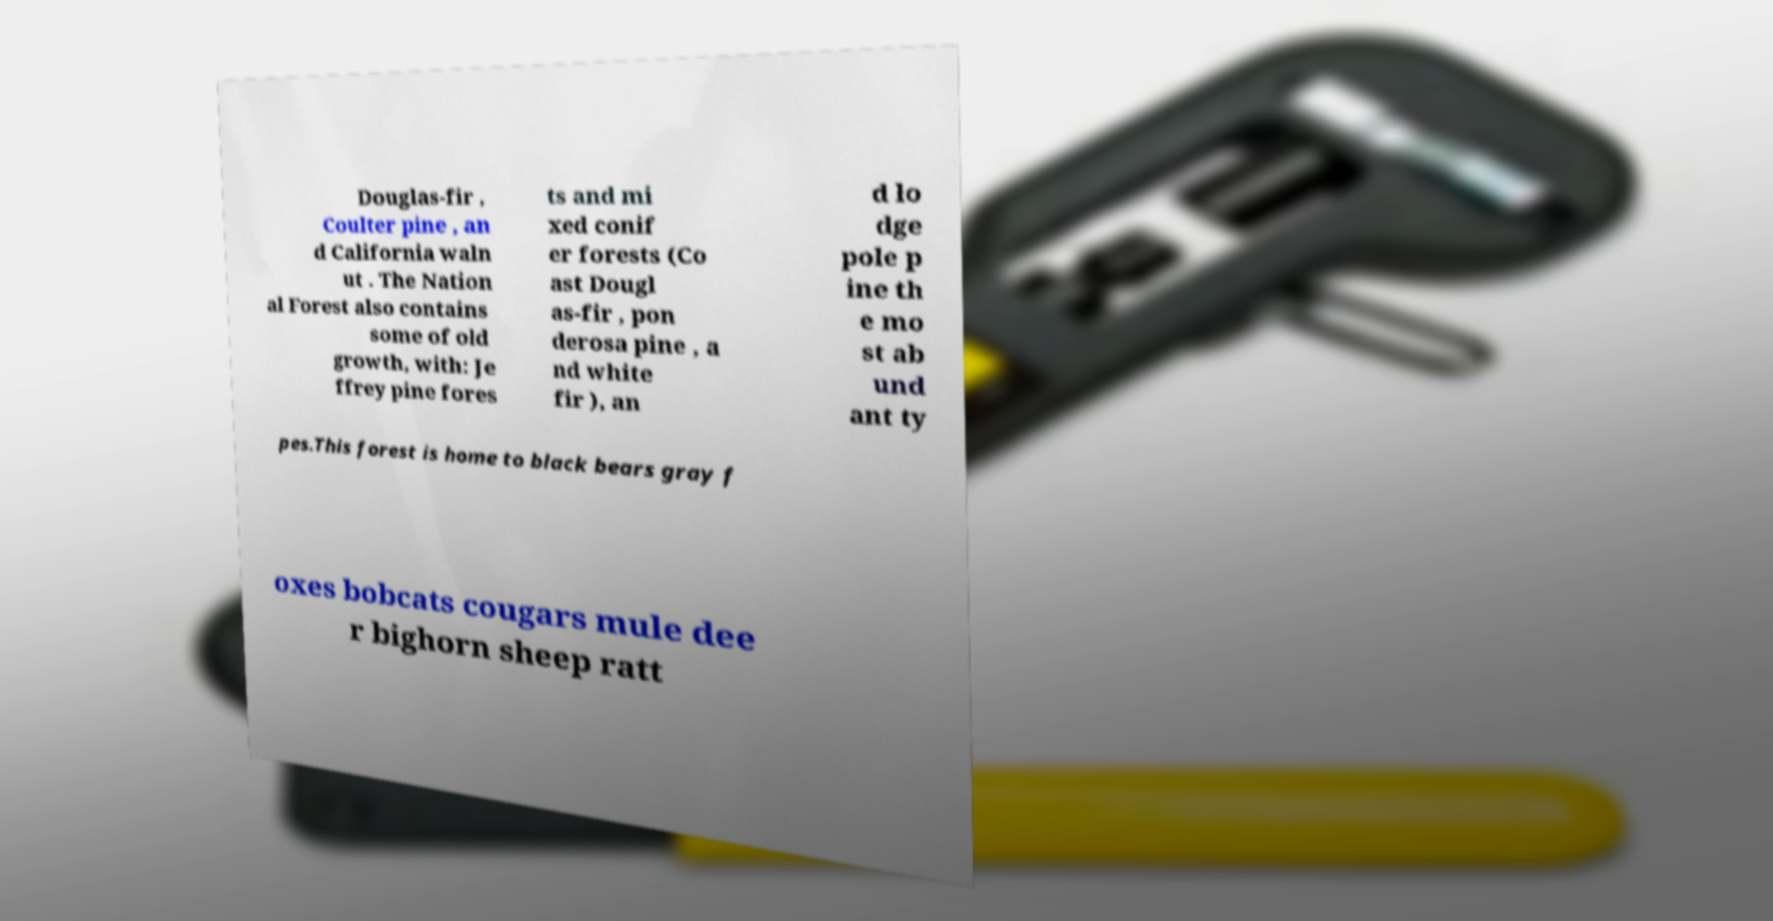Can you read and provide the text displayed in the image?This photo seems to have some interesting text. Can you extract and type it out for me? Douglas-fir , Coulter pine , an d California waln ut . The Nation al Forest also contains some of old growth, with: Je ffrey pine fores ts and mi xed conif er forests (Co ast Dougl as-fir , pon derosa pine , a nd white fir ), an d lo dge pole p ine th e mo st ab und ant ty pes.This forest is home to black bears gray f oxes bobcats cougars mule dee r bighorn sheep ratt 